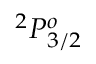Convert formula to latex. <formula><loc_0><loc_0><loc_500><loc_500>^ { 2 } P _ { 3 / 2 } ^ { o }</formula> 